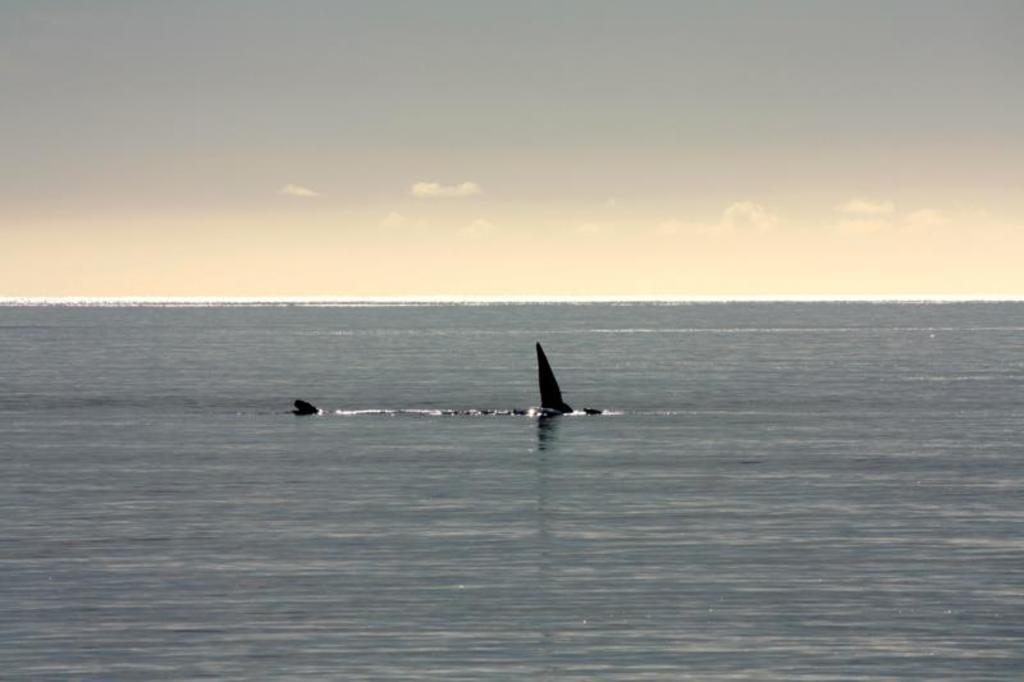What is located in the water in the image? There is an object in the water. What can be seen in the background of the image? The sky in the background is a mix of white and gray colors. What type of ring can be seen on the object in the water? There is no ring present on the object in the water in the image. 